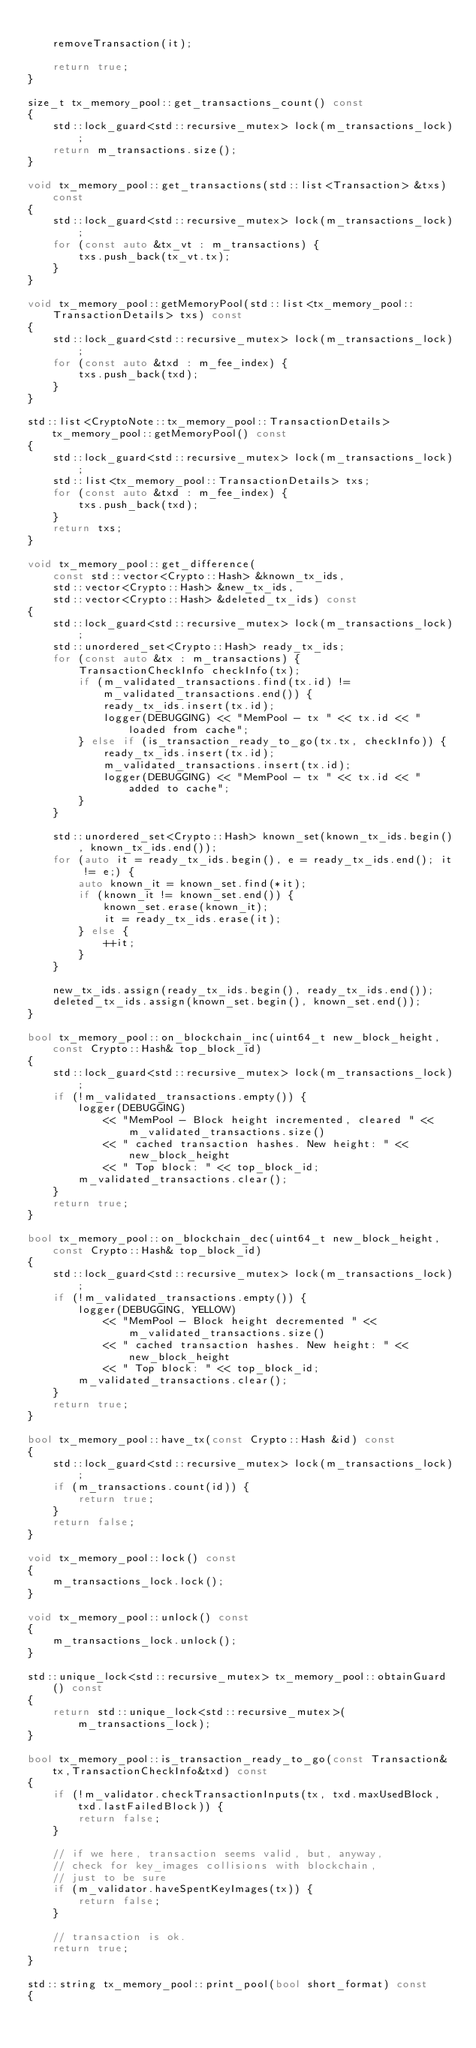<code> <loc_0><loc_0><loc_500><loc_500><_C++_>
    removeTransaction(it);

    return true;
}

size_t tx_memory_pool::get_transactions_count() const
{
    std::lock_guard<std::recursive_mutex> lock(m_transactions_lock);
    return m_transactions.size();
}

void tx_memory_pool::get_transactions(std::list<Transaction> &txs) const
{
    std::lock_guard<std::recursive_mutex> lock(m_transactions_lock);
    for (const auto &tx_vt : m_transactions) {
        txs.push_back(tx_vt.tx);
    }
}

void tx_memory_pool::getMemoryPool(std::list<tx_memory_pool::TransactionDetails> txs) const
{
    std::lock_guard<std::recursive_mutex> lock(m_transactions_lock);
    for (const auto &txd : m_fee_index) {
        txs.push_back(txd);
    }
}

std::list<CryptoNote::tx_memory_pool::TransactionDetails> tx_memory_pool::getMemoryPool() const
{
    std::lock_guard<std::recursive_mutex> lock(m_transactions_lock);
    std::list<tx_memory_pool::TransactionDetails> txs;
    for (const auto &txd : m_fee_index) {
        txs.push_back(txd);
    }
    return txs;
}

void tx_memory_pool::get_difference(
    const std::vector<Crypto::Hash> &known_tx_ids,
    std::vector<Crypto::Hash> &new_tx_ids,
    std::vector<Crypto::Hash> &deleted_tx_ids) const
{
    std::lock_guard<std::recursive_mutex> lock(m_transactions_lock);
    std::unordered_set<Crypto::Hash> ready_tx_ids;
    for (const auto &tx : m_transactions) {
        TransactionCheckInfo checkInfo(tx);
        if (m_validated_transactions.find(tx.id) != m_validated_transactions.end()) {
            ready_tx_ids.insert(tx.id);
            logger(DEBUGGING) << "MemPool - tx " << tx.id << " loaded from cache";
        } else if (is_transaction_ready_to_go(tx.tx, checkInfo)) {
            ready_tx_ids.insert(tx.id);
            m_validated_transactions.insert(tx.id);
            logger(DEBUGGING) << "MemPool - tx " << tx.id << " added to cache";
        }
    }

    std::unordered_set<Crypto::Hash> known_set(known_tx_ids.begin(), known_tx_ids.end());
    for (auto it = ready_tx_ids.begin(), e = ready_tx_ids.end(); it != e;) {
        auto known_it = known_set.find(*it);
        if (known_it != known_set.end()) {
            known_set.erase(known_it);
            it = ready_tx_ids.erase(it);
        } else {
            ++it;
        }
    }

    new_tx_ids.assign(ready_tx_ids.begin(), ready_tx_ids.end());
    deleted_tx_ids.assign(known_set.begin(), known_set.end());
}

bool tx_memory_pool::on_blockchain_inc(uint64_t new_block_height, const Crypto::Hash& top_block_id)
{
    std::lock_guard<std::recursive_mutex> lock(m_transactions_lock);
    if (!m_validated_transactions.empty()) {
        logger(DEBUGGING)
            << "MemPool - Block height incremented, cleared " << m_validated_transactions.size()
            << " cached transaction hashes. New height: " << new_block_height
            << " Top block: " << top_block_id;
        m_validated_transactions.clear();
    }
    return true;
}

bool tx_memory_pool::on_blockchain_dec(uint64_t new_block_height, const Crypto::Hash& top_block_id)
{
    std::lock_guard<std::recursive_mutex> lock(m_transactions_lock);
    if (!m_validated_transactions.empty()) {
        logger(DEBUGGING, YELLOW)
            << "MemPool - Block height decremented " << m_validated_transactions.size()
            << " cached transaction hashes. New height: " << new_block_height
            << " Top block: " << top_block_id;
        m_validated_transactions.clear();
    }
    return true;
}

bool tx_memory_pool::have_tx(const Crypto::Hash &id) const
{
    std::lock_guard<std::recursive_mutex> lock(m_transactions_lock);
    if (m_transactions.count(id)) {
        return true;
    }
    return false;
}

void tx_memory_pool::lock() const
{
    m_transactions_lock.lock();
}

void tx_memory_pool::unlock() const
{
    m_transactions_lock.unlock();
}

std::unique_lock<std::recursive_mutex> tx_memory_pool::obtainGuard() const
{
    return std::unique_lock<std::recursive_mutex>(m_transactions_lock);
}

bool tx_memory_pool::is_transaction_ready_to_go(const Transaction&tx,TransactionCheckInfo&txd) const
{
    if (!m_validator.checkTransactionInputs(tx, txd.maxUsedBlock, txd.lastFailedBlock)) {
        return false;
    }

    // if we here, transaction seems valid, but, anyway,
    // check for key_images collisions with blockchain,
    // just to be sure
    if (m_validator.haveSpentKeyImages(tx)) {
        return false;
    }

    // transaction is ok.
    return true;
}

std::string tx_memory_pool::print_pool(bool short_format) const
{</code> 